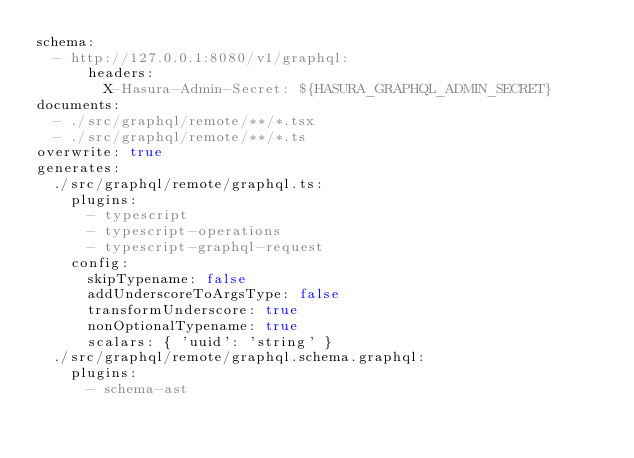Convert code to text. <code><loc_0><loc_0><loc_500><loc_500><_YAML_>schema:
  - http://127.0.0.1:8080/v1/graphql:
      headers:
        X-Hasura-Admin-Secret: ${HASURA_GRAPHQL_ADMIN_SECRET}
documents:
  - ./src/graphql/remote/**/*.tsx
  - ./src/graphql/remote/**/*.ts
overwrite: true
generates:
  ./src/graphql/remote/graphql.ts:
    plugins:
      - typescript
      - typescript-operations
      - typescript-graphql-request
    config:
      skipTypename: false
      addUnderscoreToArgsType: false
      transformUnderscore: true
      nonOptionalTypename: true
      scalars: { 'uuid': 'string' }
  ./src/graphql/remote/graphql.schema.graphql:
    plugins:
      - schema-ast
</code> 